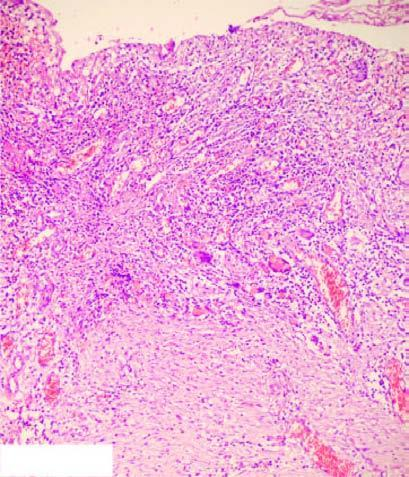what are illustrated in the diagram?
Answer the question using a single word or phrase. Histologic zones of the ulcer 